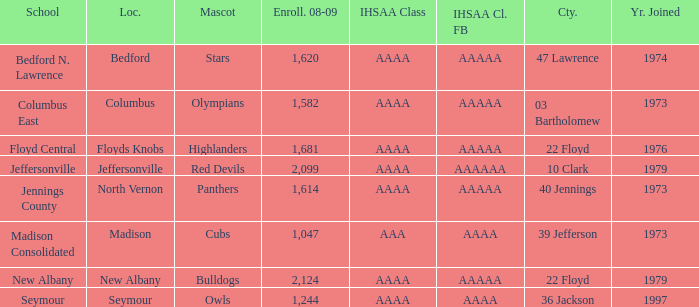What school is in 36 Jackson? Seymour. 